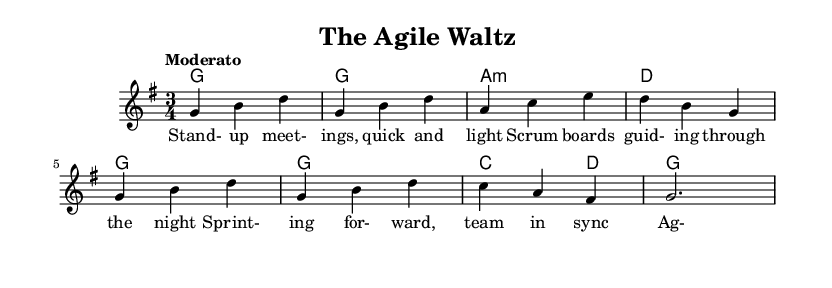What is the key signature of this music? The key signature shown is G major, which consists of one sharp (F#). This is indicated at the beginning of the staff where the key signature is placed.
Answer: G major What is the time signature of this music? The time signature is indicated as 3/4, which means there are three beats in each measure and the quarter note gets one beat. This is located at the beginning of the sheet music.
Answer: 3/4 What is the tempo marking of this piece? The tempo marking is "Moderato", which indicates a moderate speed. This is typically indicated at the start of the piece, reflecting how fast the music should be played.
Answer: Moderato How many measures are in the melody section? By counting the melody notes and the bar lines, we find there are eight measures indicated by the separation of notes into distinct groups.
Answer: Eight What chord follows the G major chord? The chord following G major is A minor, which can be identified by looking at the chord symbols above the staff, indicating the harmonic progression.
Answer: A minor Which lyric corresponds to the first measure of music? The lyric corresponding to the first measure is "Stand-up meetings, quick and light," which can be matched by referring to the lyrics under the melody notes.
Answer: Stand-up meetings, quick and light What is the last note of the melody before the final chord? The last note of the melody before the final chord is G, which is the note seen just before the final barline. It can be noted by looking at the melody part specifically.
Answer: G 